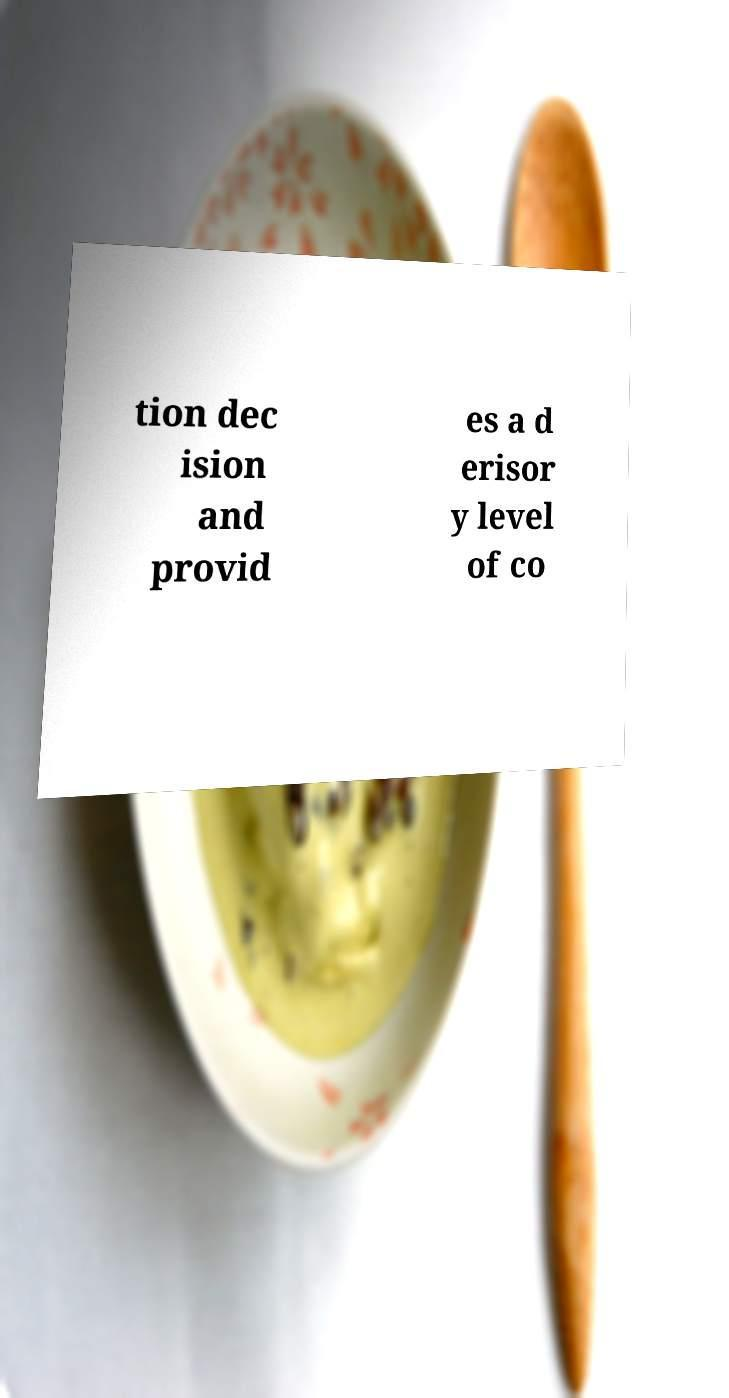Please read and relay the text visible in this image. What does it say? tion dec ision and provid es a d erisor y level of co 